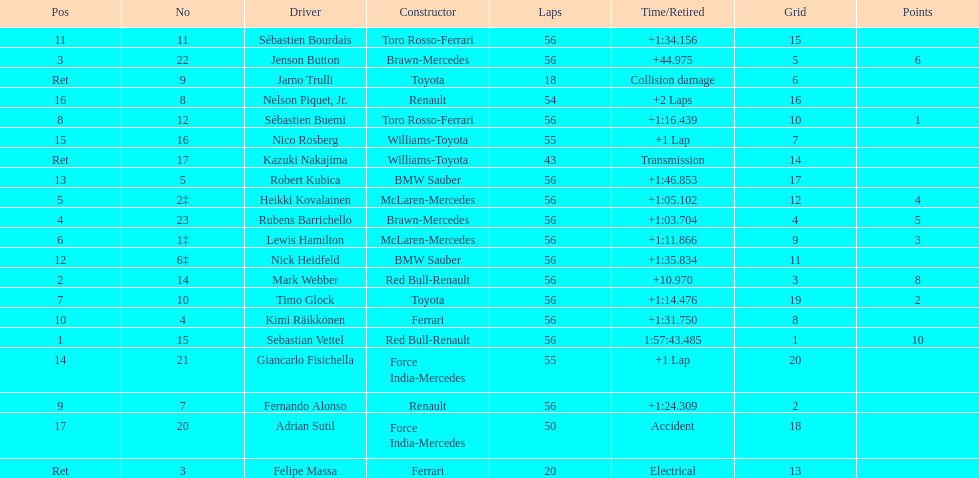What name is just previous to kazuki nakjima on the list? Adrian Sutil. 